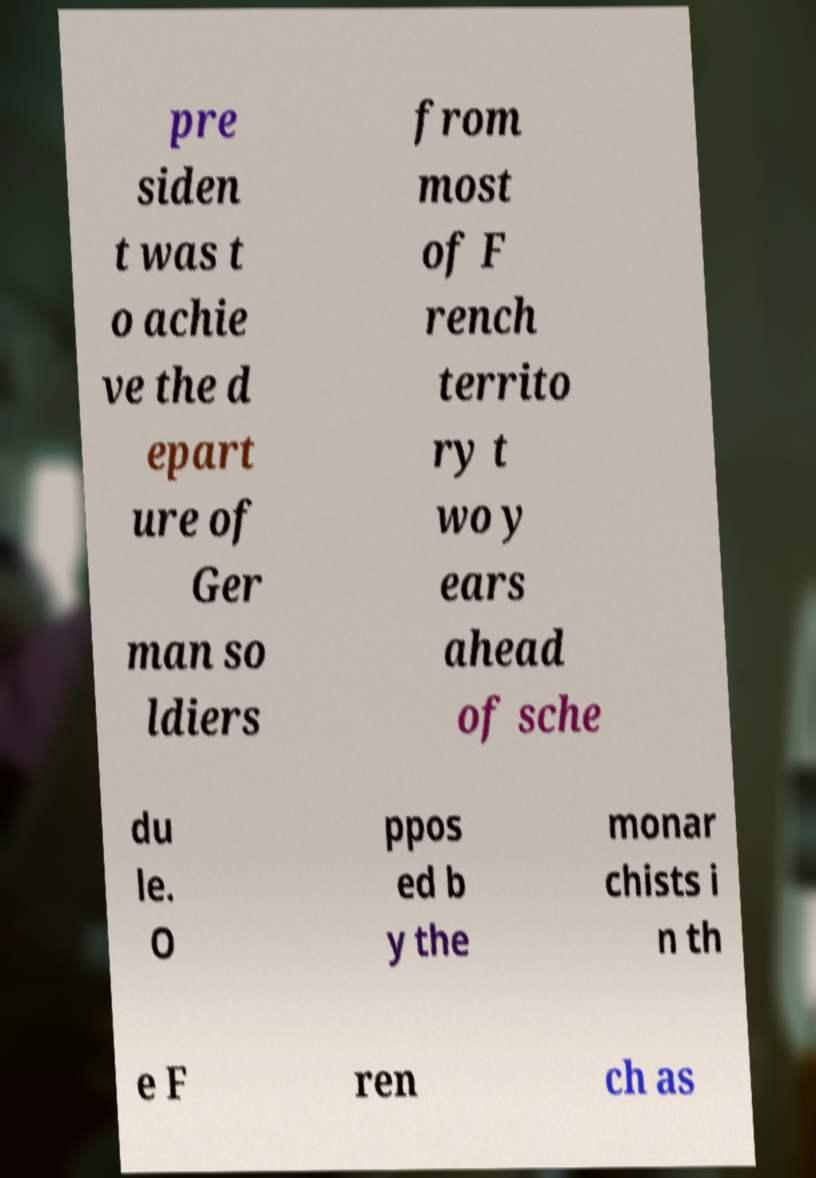I need the written content from this picture converted into text. Can you do that? pre siden t was t o achie ve the d epart ure of Ger man so ldiers from most of F rench territo ry t wo y ears ahead of sche du le. O ppos ed b y the monar chists i n th e F ren ch as 